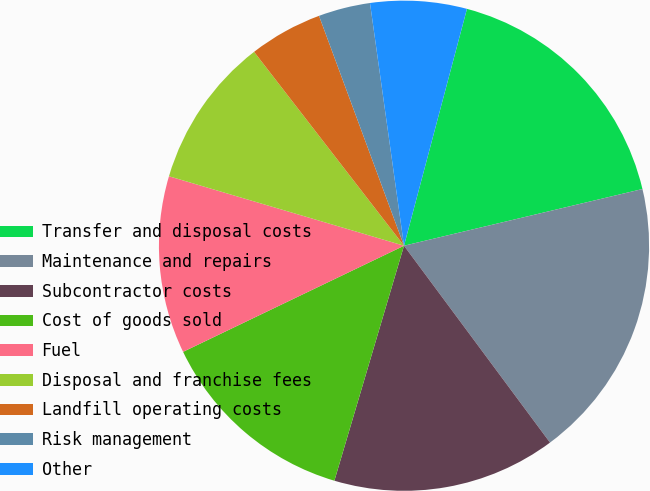Convert chart to OTSL. <chart><loc_0><loc_0><loc_500><loc_500><pie_chart><fcel>Transfer and disposal costs<fcel>Maintenance and repairs<fcel>Subcontractor costs<fcel>Cost of goods sold<fcel>Fuel<fcel>Disposal and franchise fees<fcel>Landfill operating costs<fcel>Risk management<fcel>Other<nl><fcel>17.15%<fcel>18.56%<fcel>14.74%<fcel>13.29%<fcel>11.7%<fcel>9.95%<fcel>4.84%<fcel>3.42%<fcel>6.35%<nl></chart> 